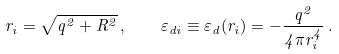<formula> <loc_0><loc_0><loc_500><loc_500>r _ { i } = \sqrt { q ^ { 2 } + R ^ { 2 } } \, , \quad \varepsilon _ { d i } \equiv \varepsilon _ { d } ( r _ { i } ) = - \frac { q ^ { 2 } } { 4 \pi r _ { i } ^ { 4 } } \, .</formula> 